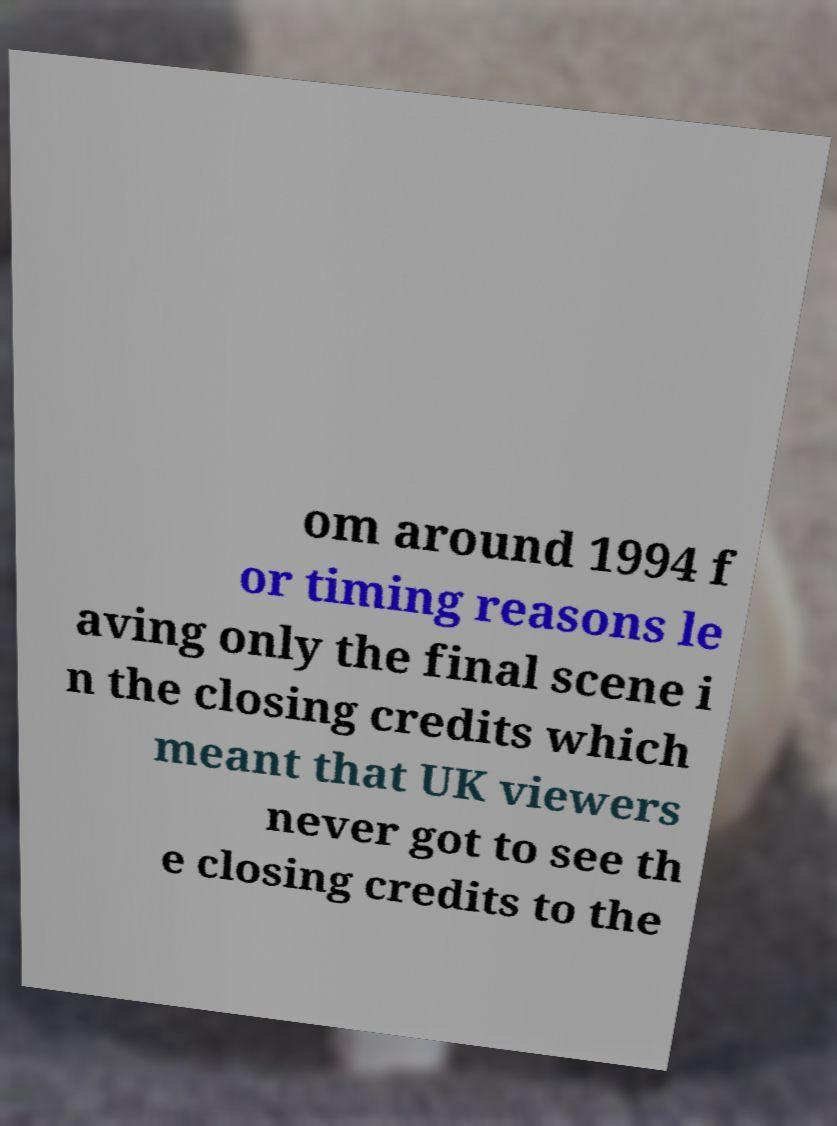There's text embedded in this image that I need extracted. Can you transcribe it verbatim? om around 1994 f or timing reasons le aving only the final scene i n the closing credits which meant that UK viewers never got to see th e closing credits to the 